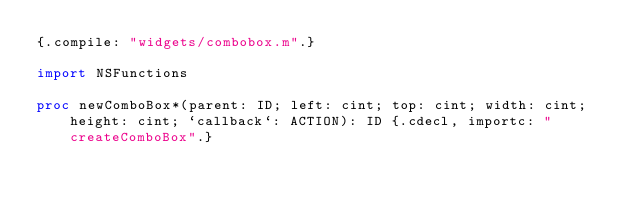<code> <loc_0><loc_0><loc_500><loc_500><_Nim_>{.compile: "widgets/combobox.m".}

import NSFunctions

proc newComboBox*(parent: ID; left: cint; top: cint; width: cint; height: cint; `callback`: ACTION): ID {.cdecl, importc: "createComboBox".}</code> 